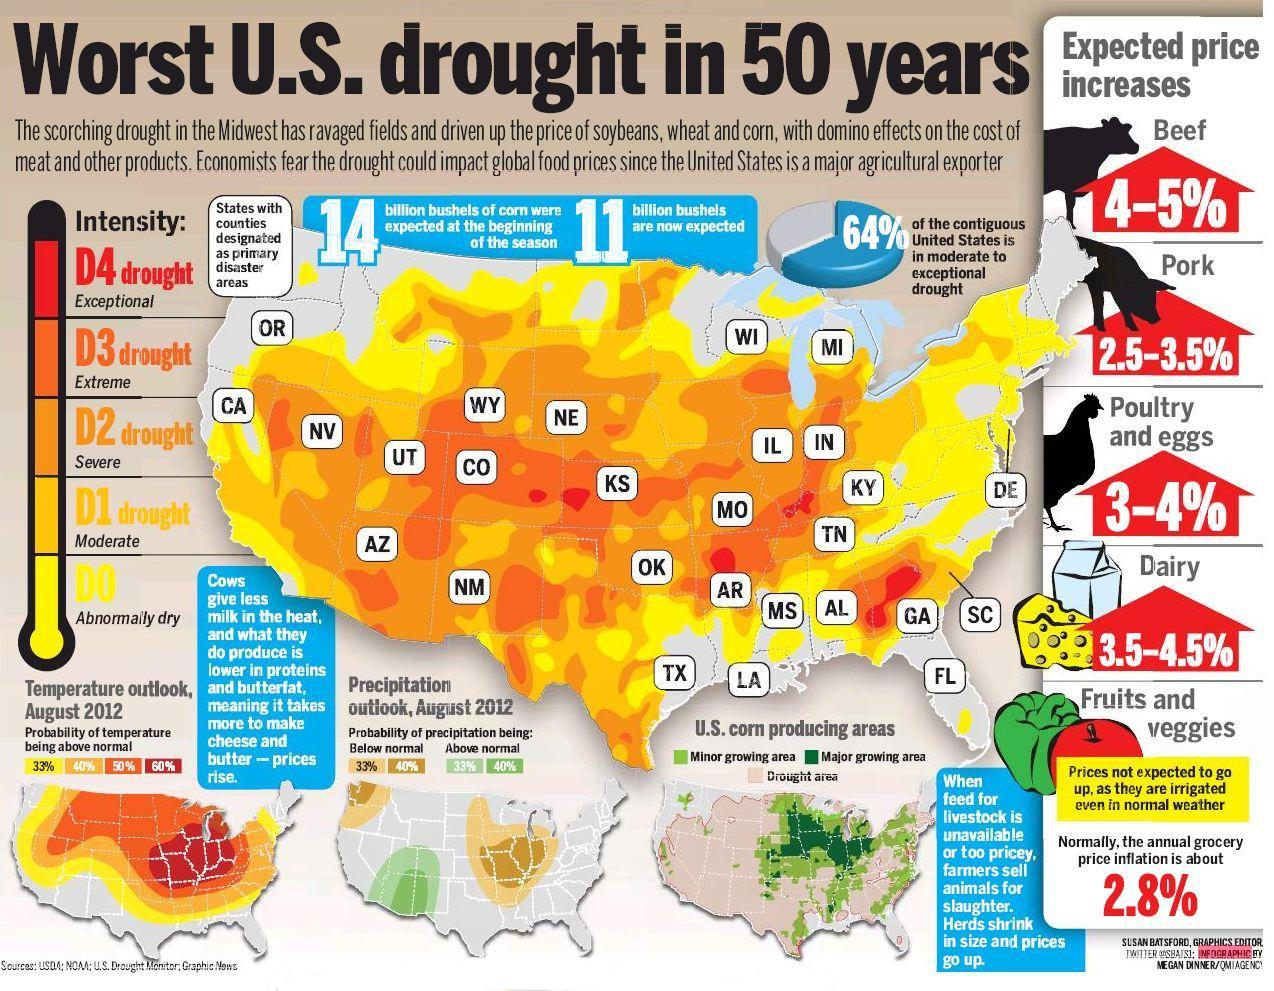which type of meat, pork or beef, is expected to have high increase in price?
Answer the question with a short phrase. beef what is the color of the capsicum shown in the picture, red or green? green what is the intensity of drought in FL? abnormally dry which south eastern state in U.S has exceptional drought intensity condition? GA whether poultry and eggs or dairy products is expected to have high increase in price? dairy The prices of fruits and veggies is not expected to go up. why? irrigated regularly which part of america is severely affected by the drought for producing corn, eastern part or western part? western part which color in the map indicates exceptional drought intensity, orange or red? red 